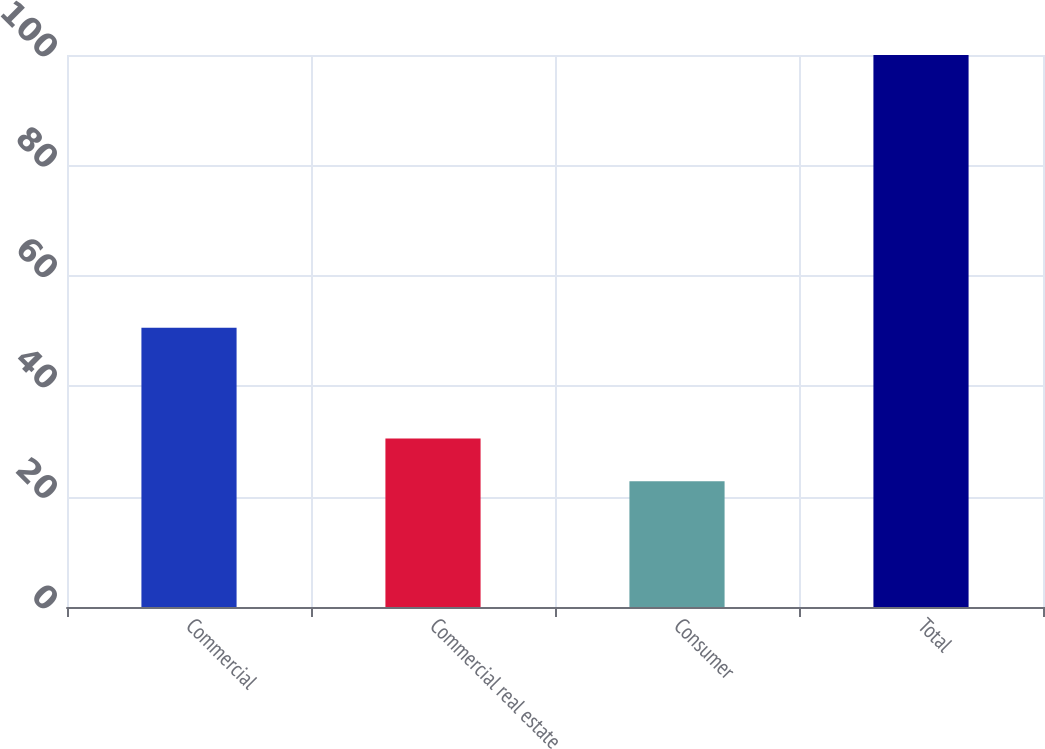<chart> <loc_0><loc_0><loc_500><loc_500><bar_chart><fcel>Commercial<fcel>Commercial real estate<fcel>Consumer<fcel>Total<nl><fcel>50.6<fcel>30.52<fcel>22.8<fcel>100<nl></chart> 